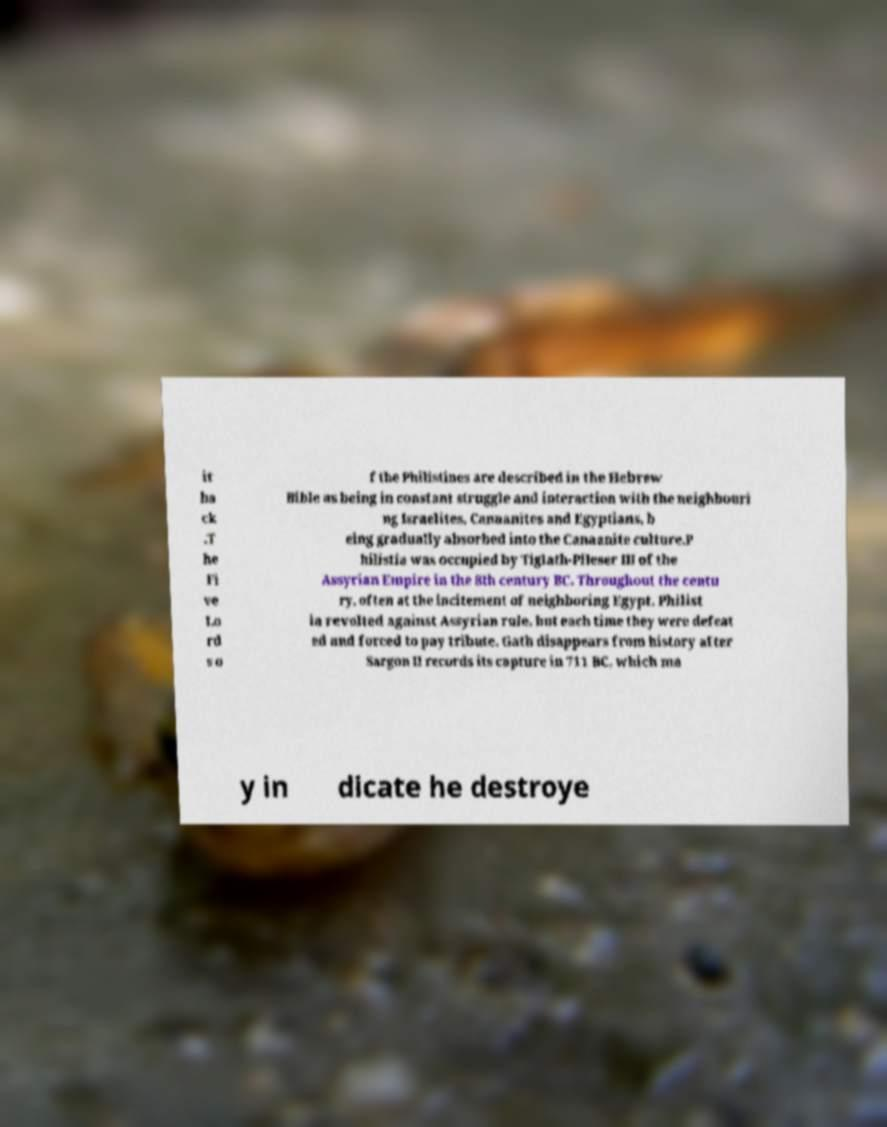Could you assist in decoding the text presented in this image and type it out clearly? it ba ck .T he Fi ve Lo rd s o f the Philistines are described in the Hebrew Bible as being in constant struggle and interaction with the neighbouri ng Israelites, Canaanites and Egyptians, b eing gradually absorbed into the Canaanite culture.P hilistia was occupied by Tiglath-Pileser III of the Assyrian Empire in the 8th century BC. Throughout the centu ry, often at the incitement of neighboring Egypt, Philist ia revolted against Assyrian rule, but each time they were defeat ed and forced to pay tribute. Gath disappears from history after Sargon II records its capture in 711 BC, which ma y in dicate he destroye 